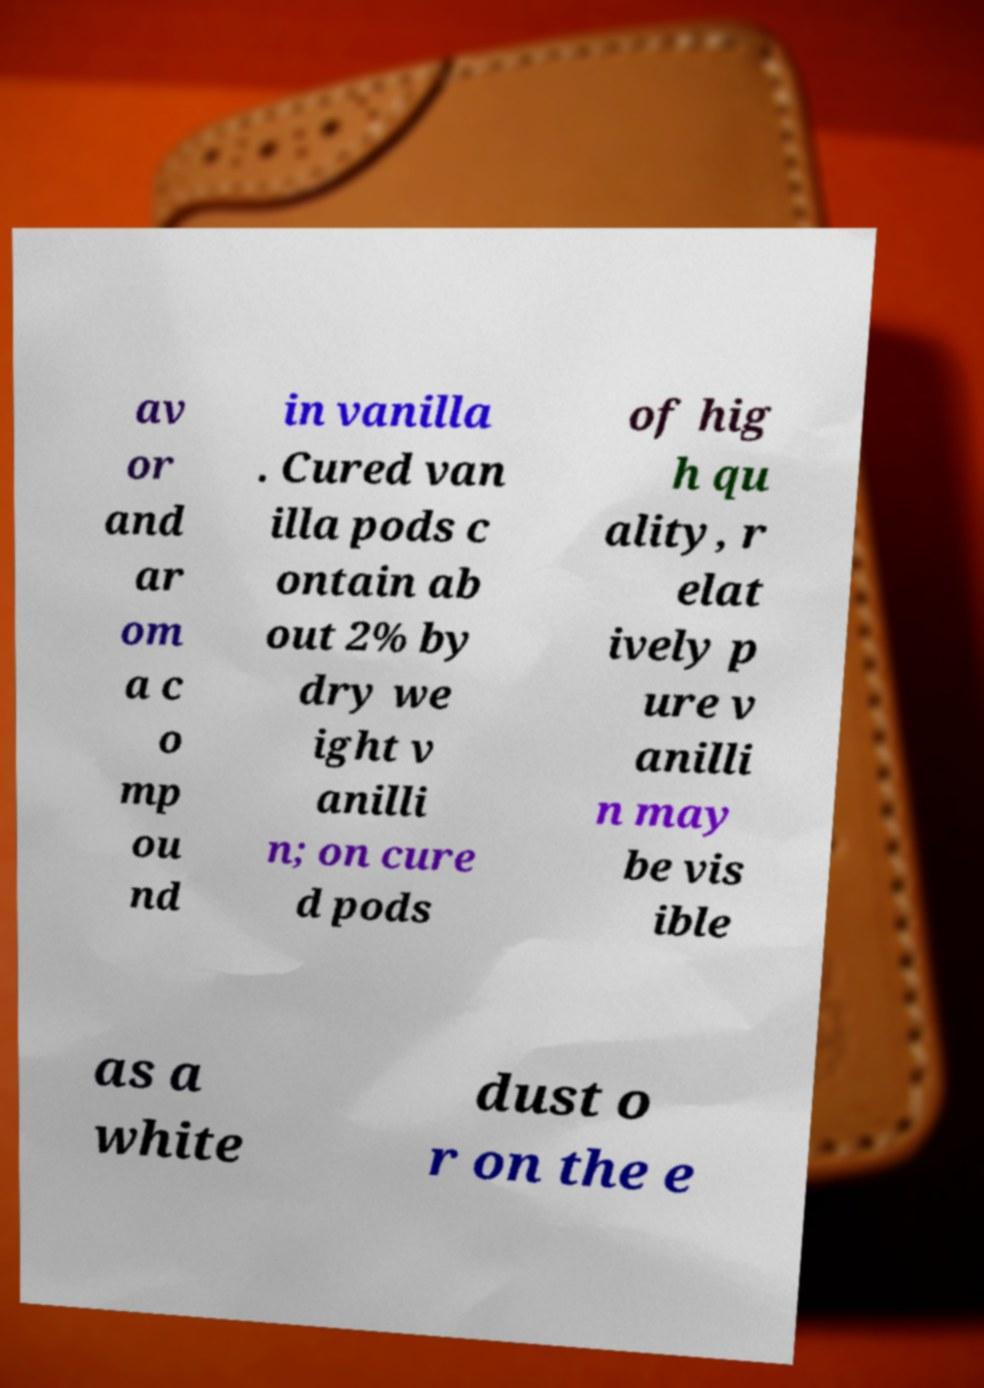I need the written content from this picture converted into text. Can you do that? av or and ar om a c o mp ou nd in vanilla . Cured van illa pods c ontain ab out 2% by dry we ight v anilli n; on cure d pods of hig h qu ality, r elat ively p ure v anilli n may be vis ible as a white dust o r on the e 